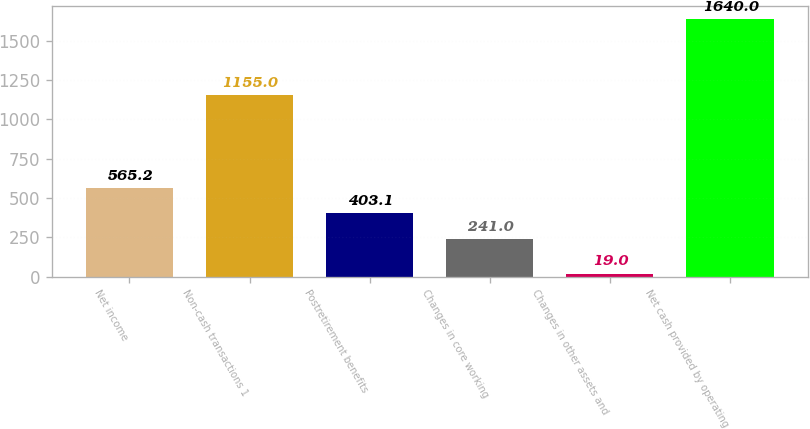<chart> <loc_0><loc_0><loc_500><loc_500><bar_chart><fcel>Net income<fcel>Non-cash transactions 1<fcel>Postretirement benefits<fcel>Changes in core working<fcel>Changes in other assets and<fcel>Net cash provided by operating<nl><fcel>565.2<fcel>1155<fcel>403.1<fcel>241<fcel>19<fcel>1640<nl></chart> 